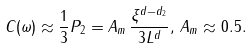Convert formula to latex. <formula><loc_0><loc_0><loc_500><loc_500>C ( \omega ) \approx \frac { 1 } { 3 } P _ { 2 } = A _ { m } \, \frac { \xi ^ { d - d _ { 2 } } } { 3 L ^ { d } } , \, A _ { m } \approx 0 . 5 .</formula> 